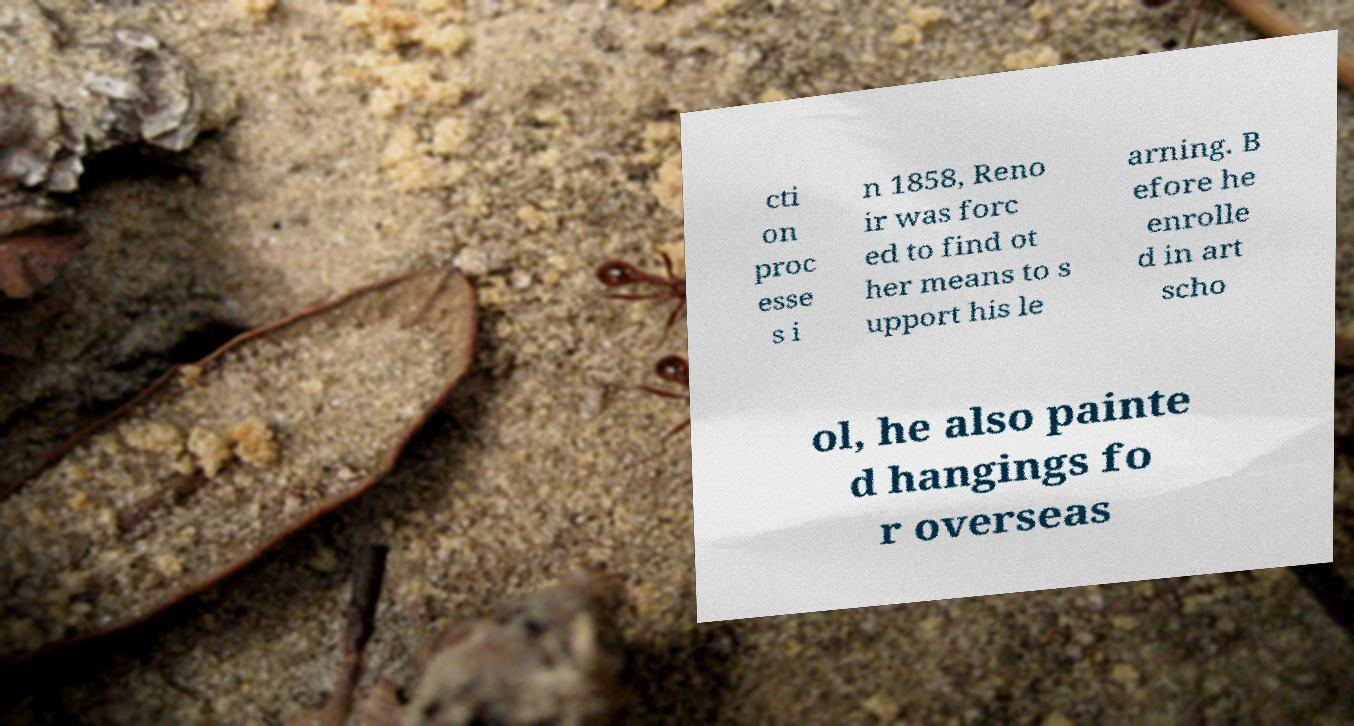Could you extract and type out the text from this image? cti on proc esse s i n 1858, Reno ir was forc ed to find ot her means to s upport his le arning. B efore he enrolle d in art scho ol, he also painte d hangings fo r overseas 